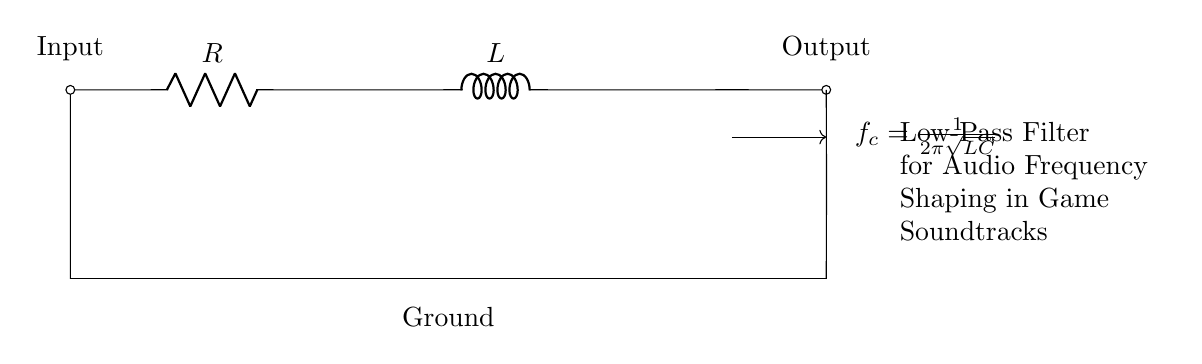What are the components in this circuit? The components visible in the circuit are a resistor labeled R and an inductor labeled L. These components are connected in series between an input and output terminal.
Answer: Resistor and Inductor What is the primary function of this circuit? This circuit operates as a low-pass filter, which allows low-frequency signals to pass through while attenuating higher frequencies. This is indicated by the labeling and context of use for audio frequency shaping.
Answer: Low-pass filter What is the path of current flow in the circuit? The current flows from the input on the left through the resistor R, then through the inductor L, and finally exits at the output on the right. The circuit's orientation shows a clear serial connection from input to output.
Answer: Left to right What happens to high frequencies in this circuit? High frequencies are attenuated or reduced significantly when they pass through the low-pass filter, which is characterized by the resistor and inductor design. The interaction of these components specifically impedes high-frequency signals.
Answer: Attenuated What is the cutoff frequency formula provided in the circuit? The formula for the cutoff frequency f_c is presented in the circuit as f_c = 1 divided by 2π times the square root of the product of L and C. This formula defines the frequency at which the output signal will be reduced by 3 decibels.
Answer: 1/2π√(LC) What is the significance of the ground in this circuit? Ground serves as a common reference point for the circuit, ensuring stability and proper functioning of the components by providing a return path for the current. It connects all components to zero volts, which is critical for consistent operation.
Answer: Reference point What is the effect of increasing the inductance in this circuit? Increasing the inductance will lower the cutoff frequency of the low-pass filter according to the formula, allowing more lower frequencies to pass through while blocking more high frequencies. This changes the filtering characteristics of the circuit.
Answer: Lower cutoff frequency 